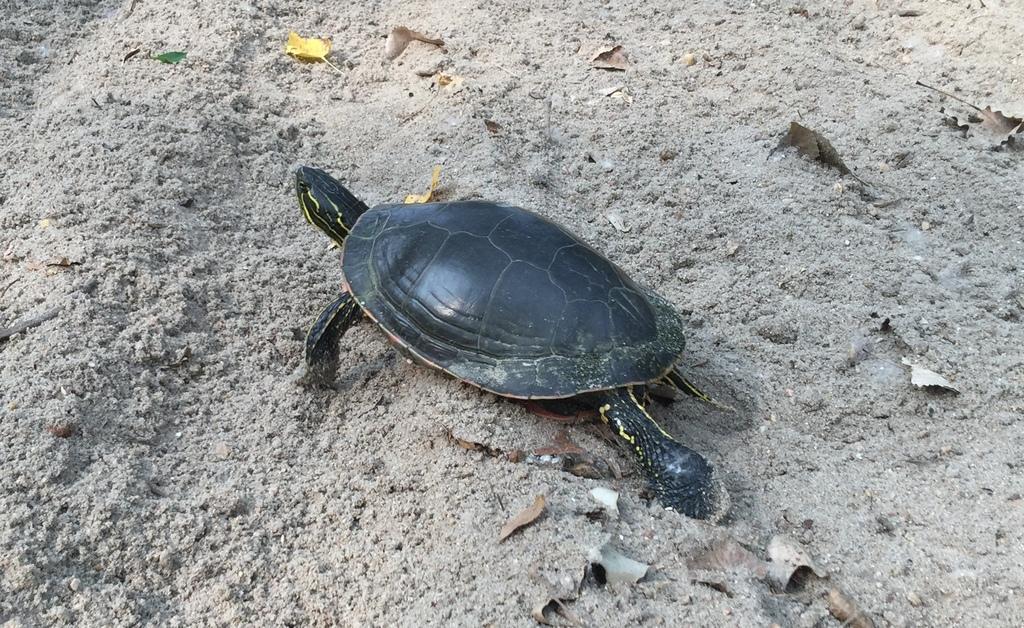How would you summarize this image in a sentence or two? In this image there is a tortoise on a land and there are leaves. 